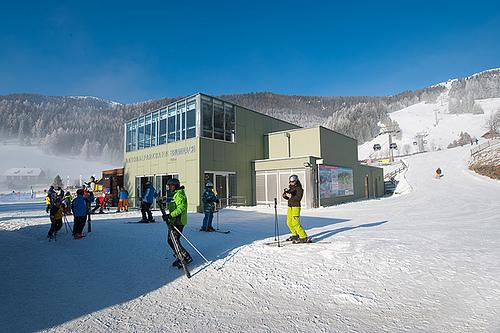What type of sport might be popular in this image setting? Skiing is the popular sport in this snowy mountain setting. According to the image, how do the majority of people spend their time at this location? Most people at this location are skiing, preparing to ski, or enjoying the ski center activities, such as sitting at the ski lodge or taking the ski lift. Briefly mention the clothing and equipment of the skiers in the image. Skiers wear bright jackets, yellow pants, and silver helmets, and they carry skis and ski poles with them. Identify the color of the sky and the type of building at the ski lodge. The sky is a crystal clear blue, and the building at the ski lodge is modern with tall glass windows on the second floor. What are some notable things happening in the image? People are getting ready to go skiing, skiers are coming down the slope, and a woman in yellow ski pants and a silver helmet is preparing to ski. Describe the surroundings of the ski lodge in the image. The ski lodge is on a mountain with trees on the side and a clear blue sky above it. A ski lift runs along the slope, and there is a safety fence along the ski trail. What activities are taking place on the ski slope? People are skiing down the slope, carrying skis and ski poles, and getting ready to ski. There is also a ski lift transporting people up the mountain. Explain the season and the weather conditions depicted in the image. The season is winter, with snow covering the ground and trees. The weather is clear with a bright blue sky and no visible clouds. Give a brief description of the image atmosphere and sentiment. The atmosphere of the image is lively and bustling, with people enjoying winter sports and spending time at the ski lodge amidst beautiful snowy scenery and clear blue skies. List some important features and objects found in the image. Ski lift, snowy mountain, ski lodge, trees, clear blue sky, skiers, ski poles, safety fence, and a map on the side of the building. 